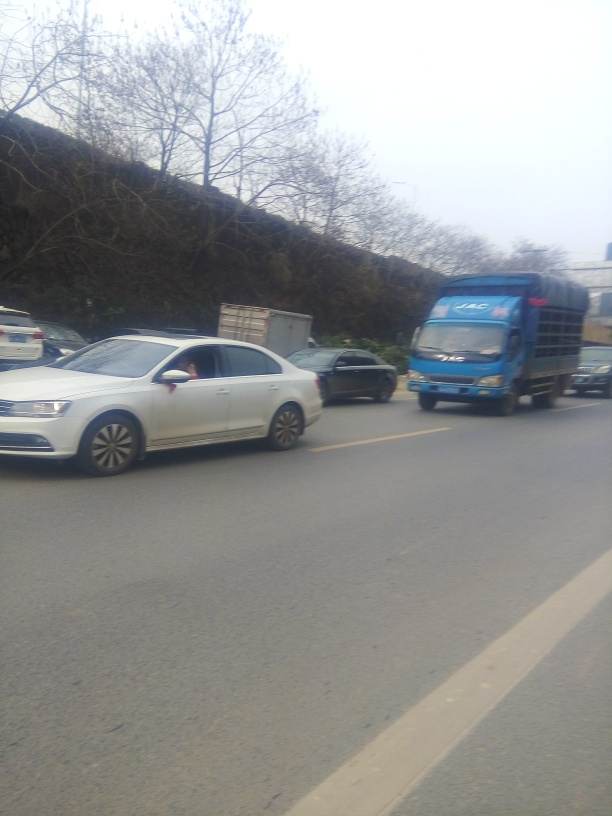What can you tell me about the surroundings? The image shows a road with vehicles and a hillside or incline on one side, lined with bare trees indicating it might be late fall or winter. The overcast sky suggests it could be a chilly or damp day. Is there anything in the image that indicates the location or region? There are no clear indicators of a specific location or region in this image. The types of vehicles and road design are quite generic and could be found in many parts of the world. To identify the location, one would likely need more contextual clues or landmarks. 